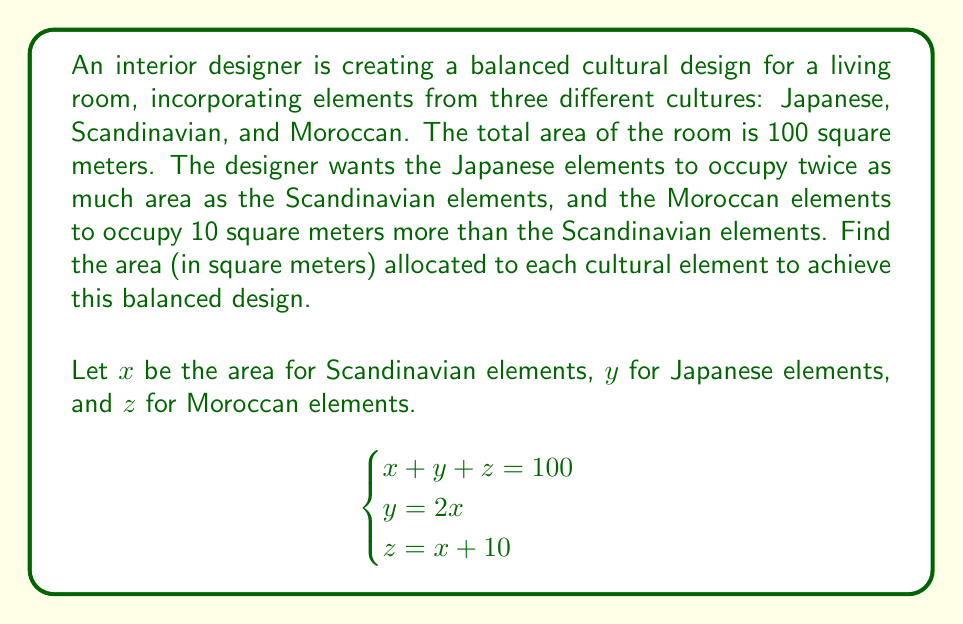Provide a solution to this math problem. To solve this system of equations, we'll use substitution:

1) From the second equation, we know that $y = 2x$

2) From the third equation, we know that $z = x + 10$

3) Substituting these into the first equation:
   $$x + 2x + (x + 10) = 100$$

4) Simplify:
   $$4x + 10 = 100$$

5) Subtract 10 from both sides:
   $$4x = 90$$

6) Divide both sides by 4:
   $$x = 22.5$$

7) Now we can find $y$ and $z$:
   $y = 2x = 2(22.5) = 45$
   $z = x + 10 = 22.5 + 10 = 32.5$

8) Verify that the sum equals 100:
   $22.5 + 45 + 32.5 = 100$

Therefore, the balanced design allocates:
- 22.5 square meters for Scandinavian elements
- 45 square meters for Japanese elements
- 32.5 square meters for Moroccan elements
Answer: Scandinavian: 22.5 sq m, Japanese: 45 sq m, Moroccan: 32.5 sq m 